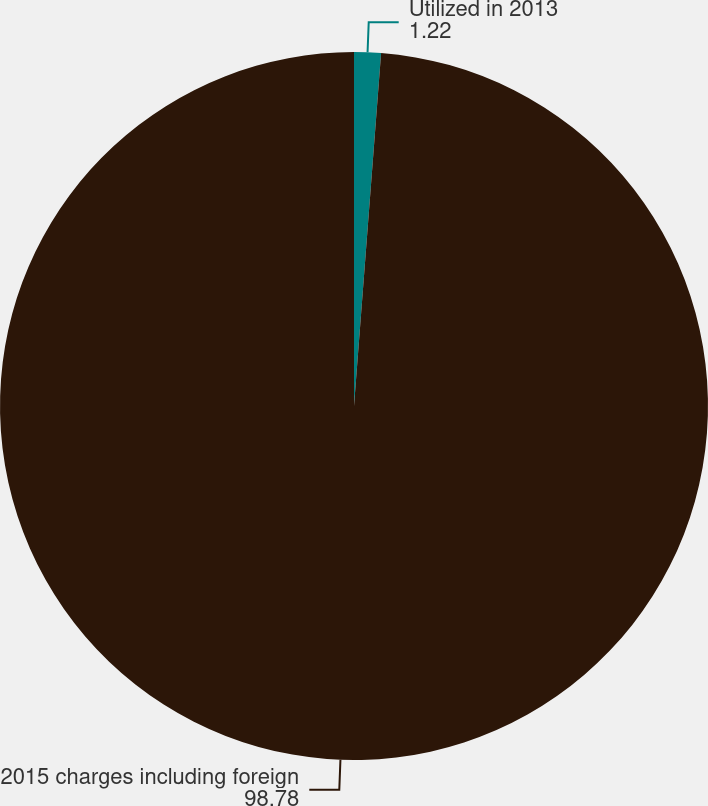Convert chart. <chart><loc_0><loc_0><loc_500><loc_500><pie_chart><fcel>Utilized in 2013<fcel>2015 charges including foreign<nl><fcel>1.22%<fcel>98.78%<nl></chart> 